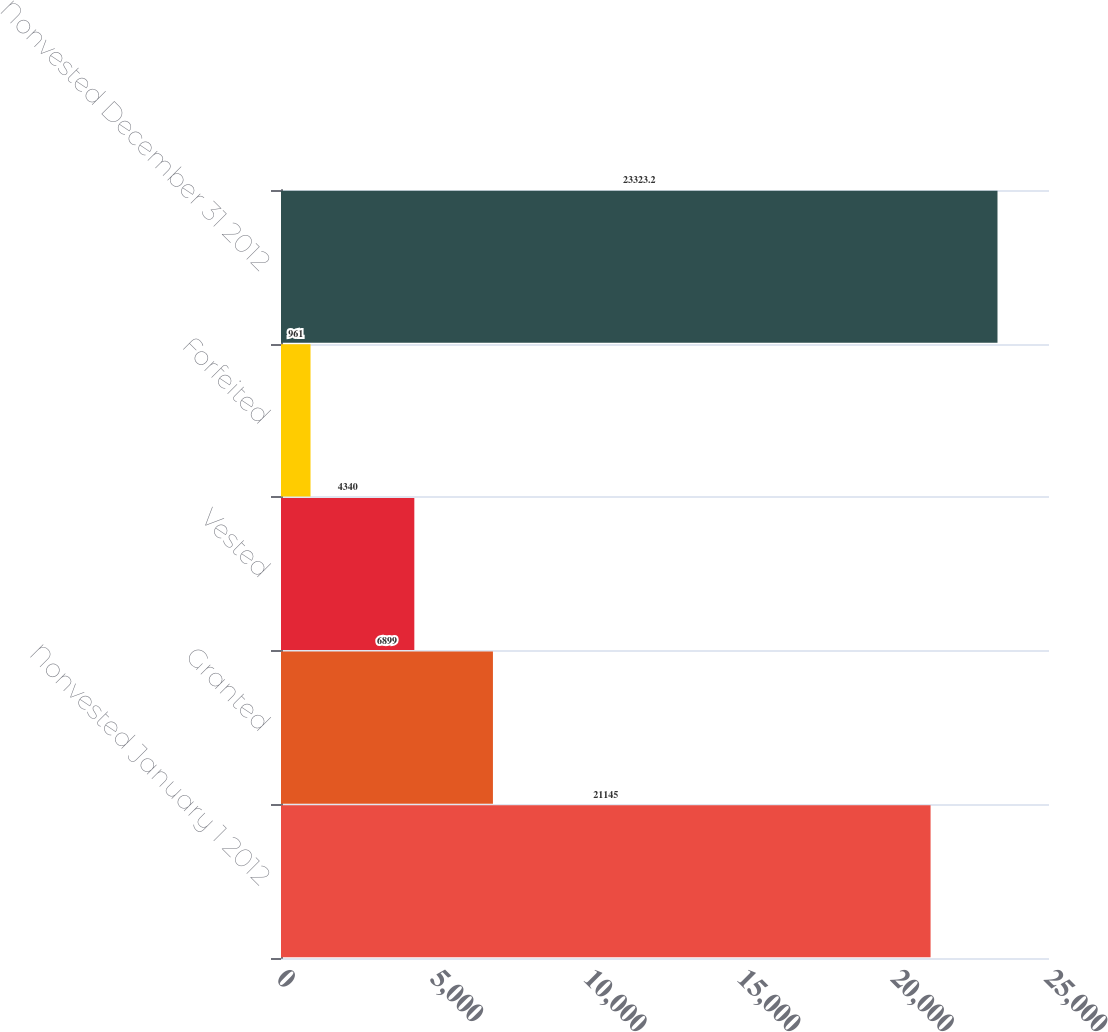Convert chart. <chart><loc_0><loc_0><loc_500><loc_500><bar_chart><fcel>Nonvested January 1 2012<fcel>Granted<fcel>Vested<fcel>Forfeited<fcel>Nonvested December 31 2012<nl><fcel>21145<fcel>6899<fcel>4340<fcel>961<fcel>23323.2<nl></chart> 